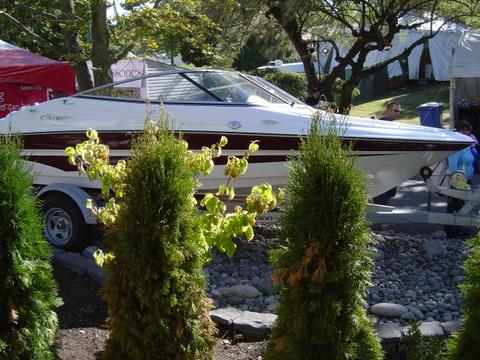What is the closest major city from this outdoor area?

Choices:
A) portland
B) seattle
C) vancouver
D) edmonton vancouver 